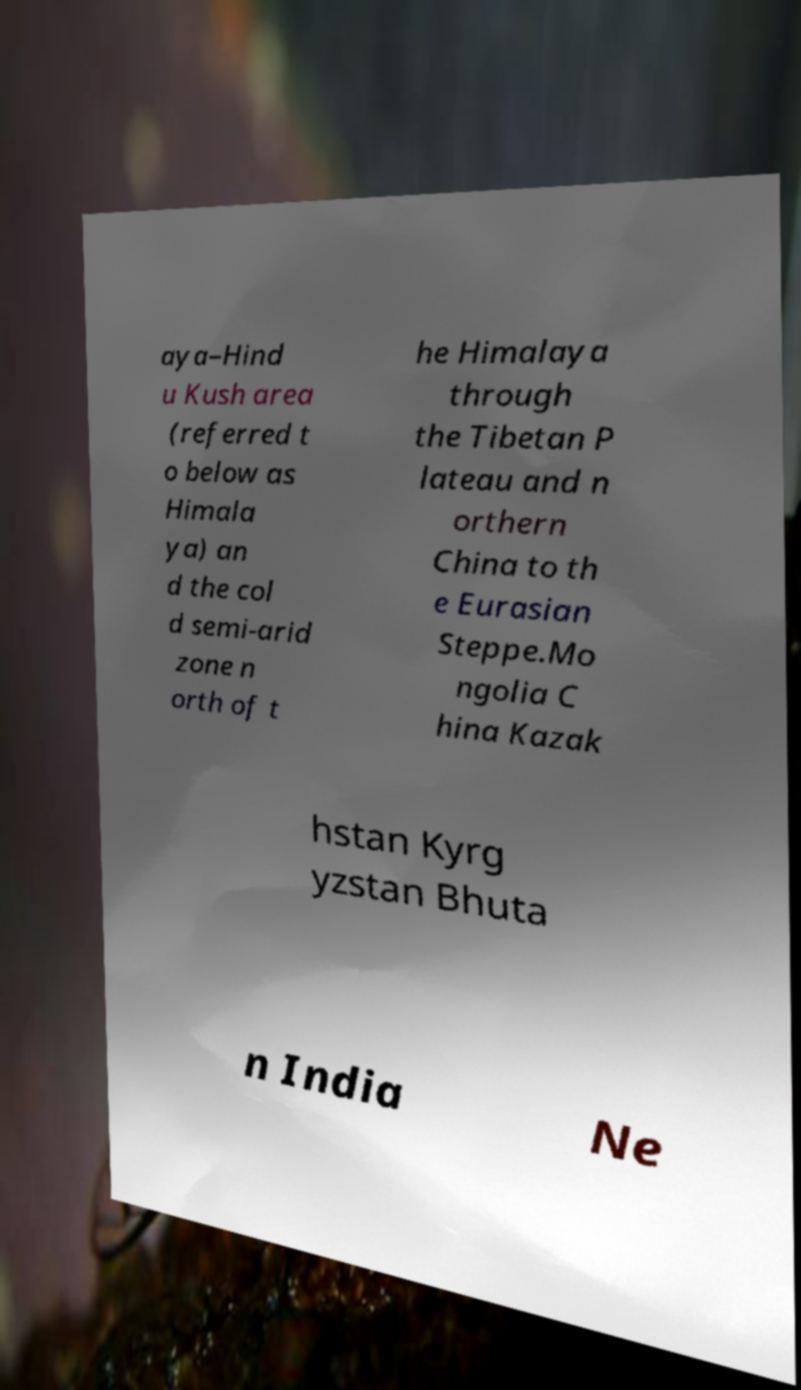Please identify and transcribe the text found in this image. aya–Hind u Kush area (referred t o below as Himala ya) an d the col d semi-arid zone n orth of t he Himalaya through the Tibetan P lateau and n orthern China to th e Eurasian Steppe.Mo ngolia C hina Kazak hstan Kyrg yzstan Bhuta n India Ne 